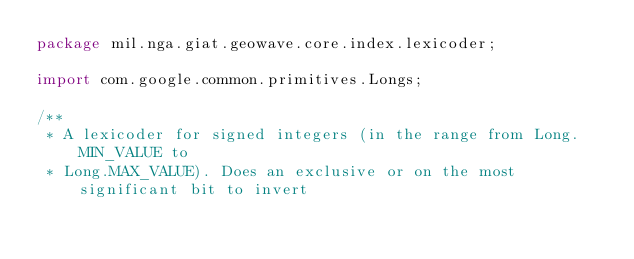Convert code to text. <code><loc_0><loc_0><loc_500><loc_500><_Java_>package mil.nga.giat.geowave.core.index.lexicoder;

import com.google.common.primitives.Longs;

/**
 * A lexicoder for signed integers (in the range from Long.MIN_VALUE to
 * Long.MAX_VALUE). Does an exclusive or on the most significant bit to invert</code> 